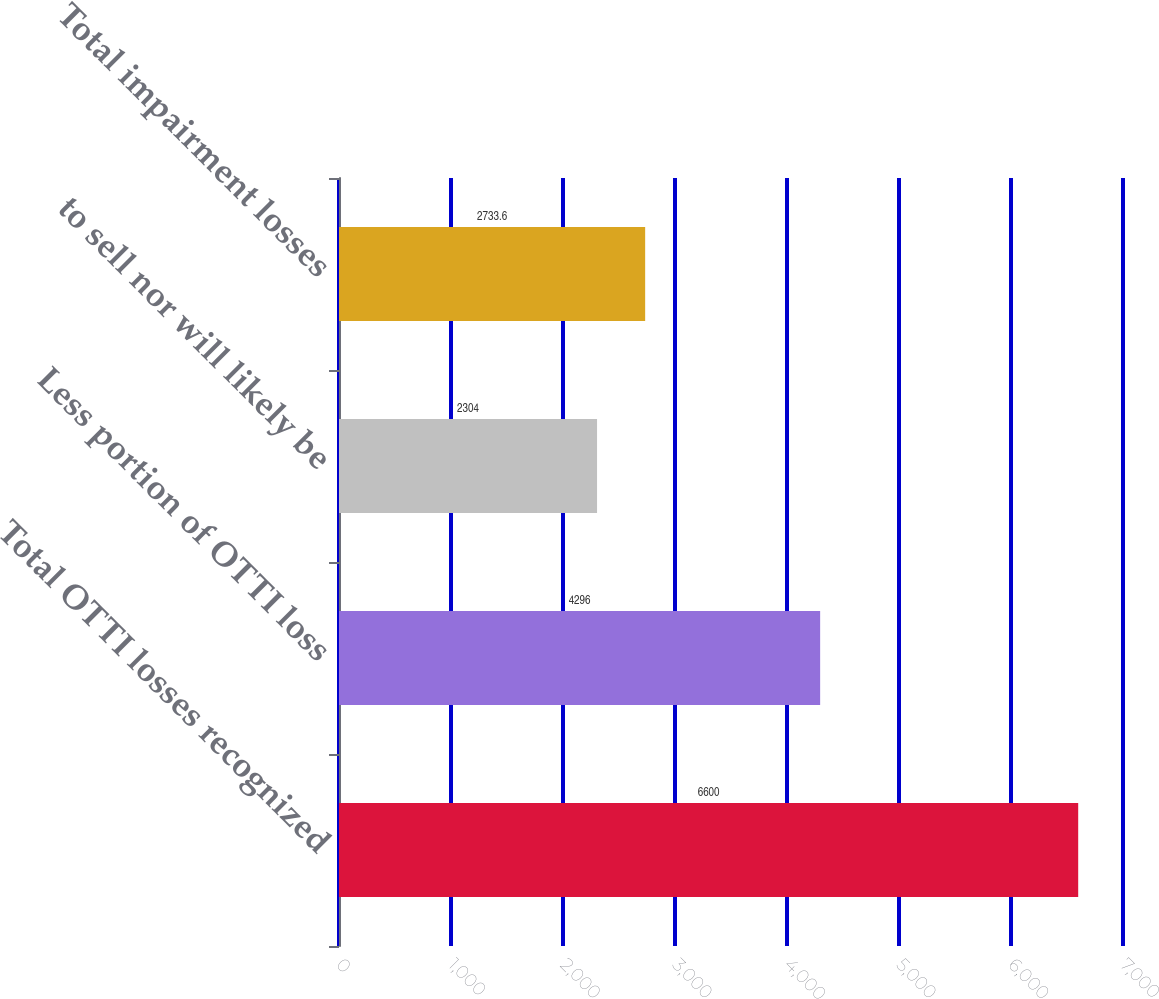Convert chart. <chart><loc_0><loc_0><loc_500><loc_500><bar_chart><fcel>Total OTTI losses recognized<fcel>Less portion of OTTI loss<fcel>to sell nor will likely be<fcel>Total impairment losses<nl><fcel>6600<fcel>4296<fcel>2304<fcel>2733.6<nl></chart> 